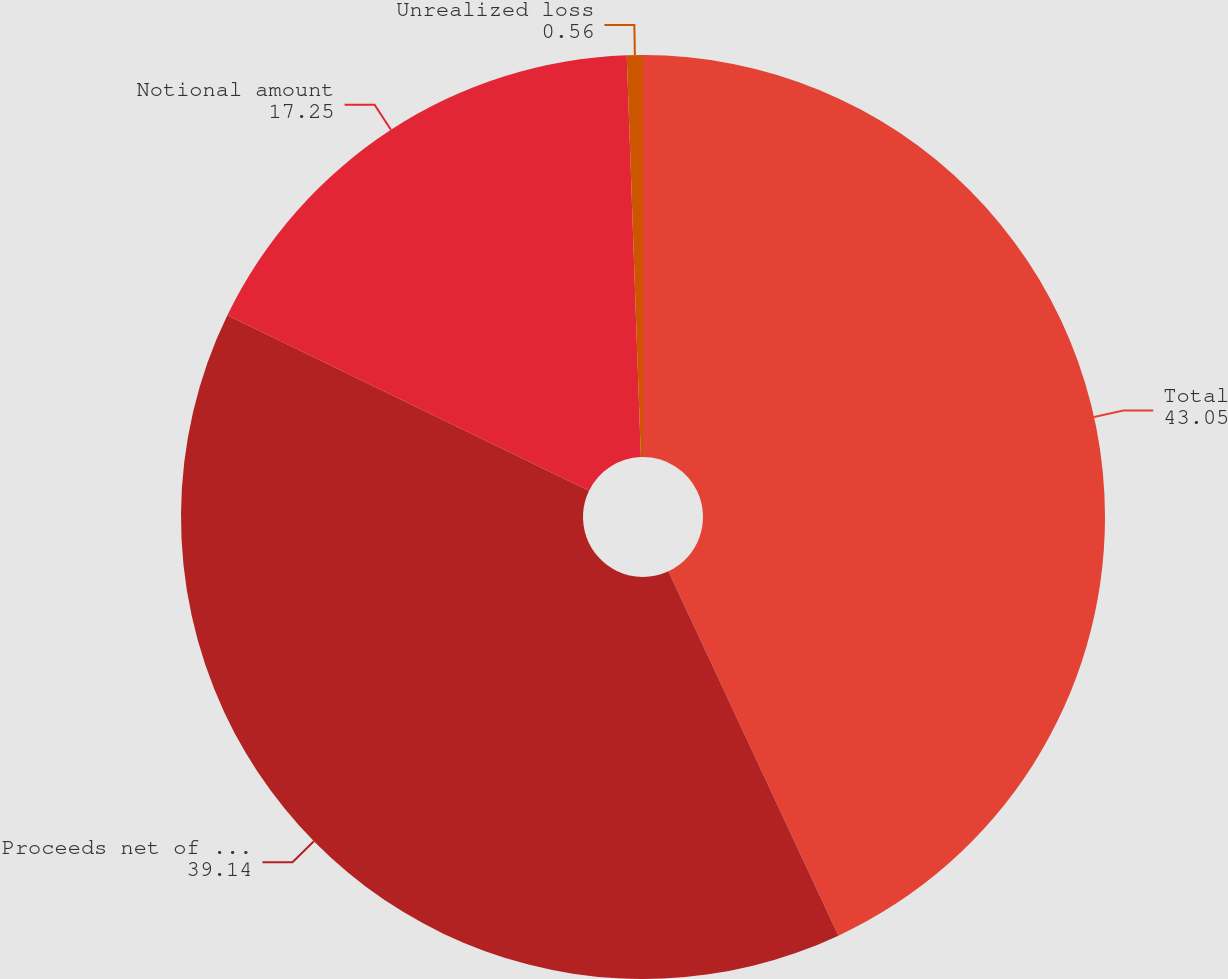Convert chart to OTSL. <chart><loc_0><loc_0><loc_500><loc_500><pie_chart><fcel>Total<fcel>Proceeds net of discount and<fcel>Notional amount<fcel>Unrealized loss<nl><fcel>43.05%<fcel>39.14%<fcel>17.25%<fcel>0.56%<nl></chart> 